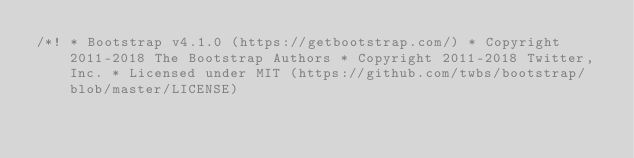<code> <loc_0><loc_0><loc_500><loc_500><_CSS_>/*! * Bootstrap v4.1.0 (https://getbootstrap.com/) * Copyright 2011-2018 The Bootstrap Authors * Copyright 2011-2018 Twitter, Inc. * Licensed under MIT (https://github.com/twbs/bootstrap/blob/master/LICENSE)</code> 